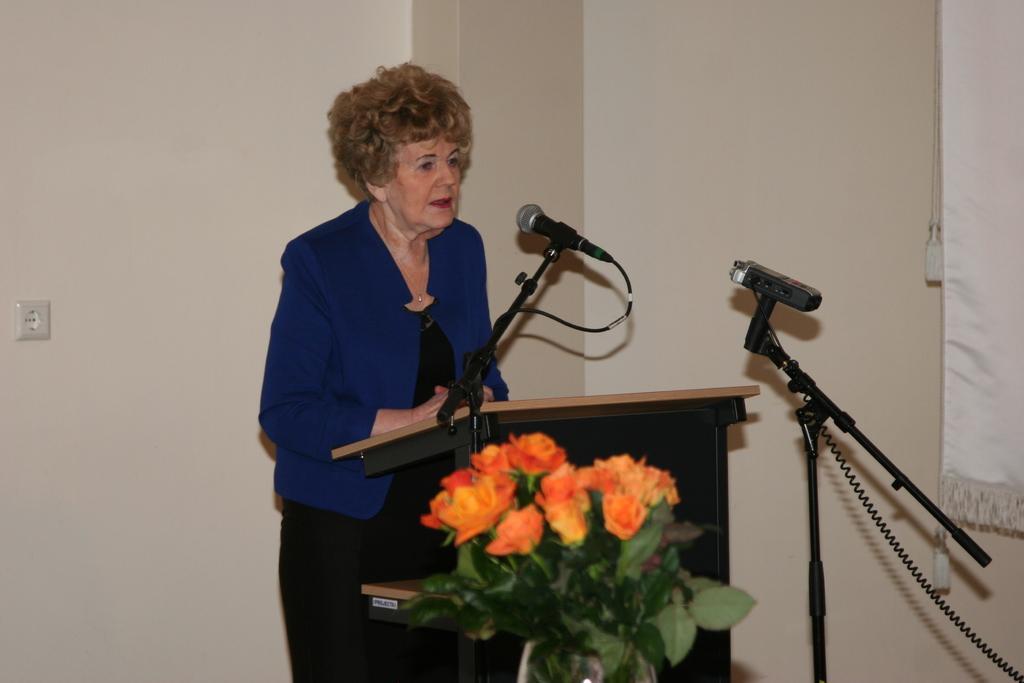In one or two sentences, can you explain what this image depicts? In this image we can see a woman wearing black color dress and blue color jacket standing behind the wooden podium on which there is a microphone and some other object in the foreground of the image we can see plant to which some flowers are grown and in the background of the image there is a wall. 